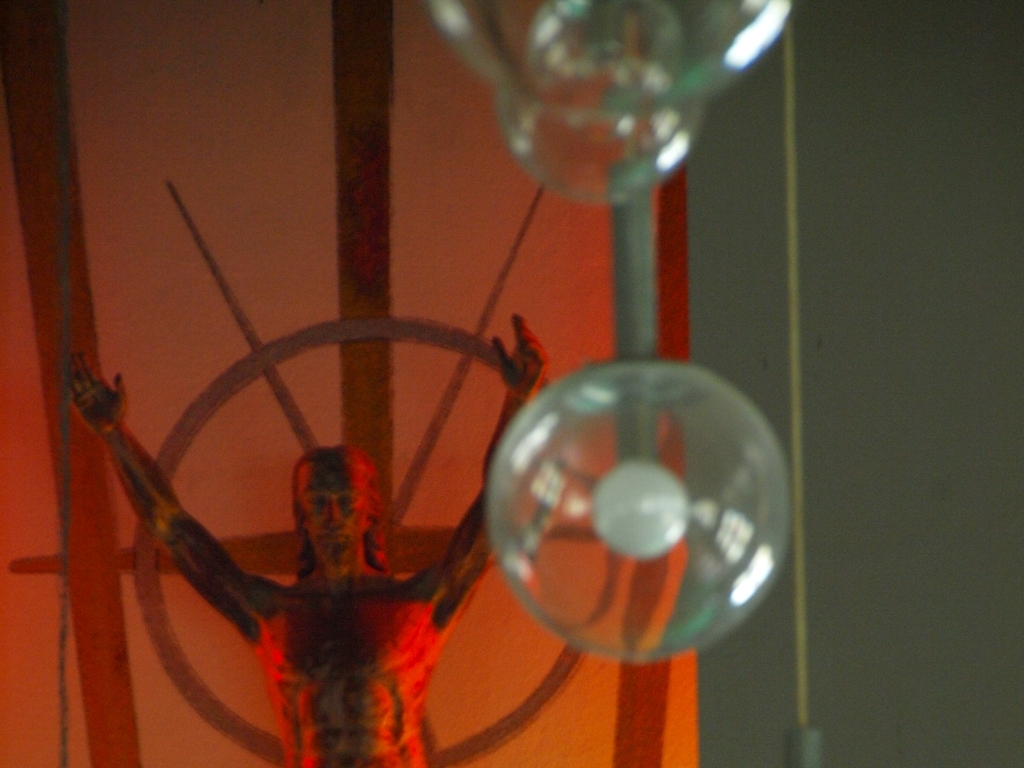Can you describe the colors used in the sculpture? The sculpture is depicted in monochromatic hues, with dominant shades of red, casting a sense of vibrant intensity. The use of red could be symbolic, possibly related to themes of passion, violence, or sacrifice, depending on the context of the piece. 